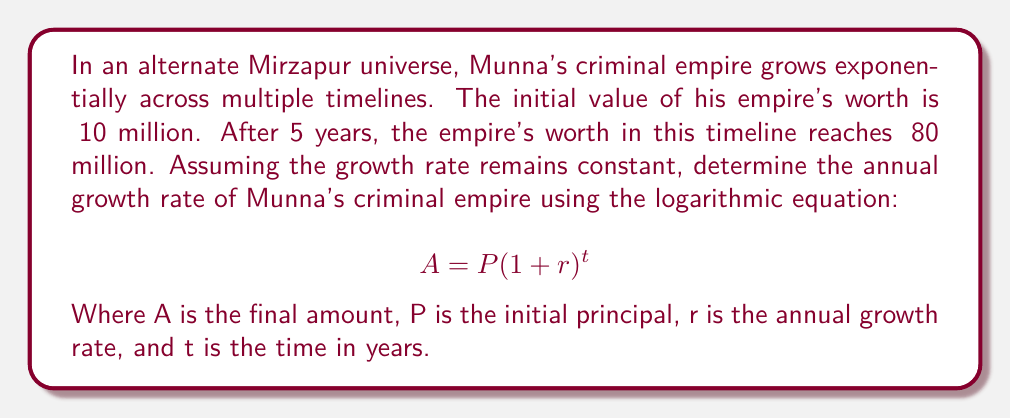Can you solve this math problem? Let's approach this step-by-step using the logarithmic properties:

1) We have the exponential growth formula: $A = P(1 + r)^t$

2) Given values:
   $P = 10$ million
   $A = 80$ million
   $t = 5$ years

3) Substituting these values into the equation:
   $80 = 10(1 + r)^5$

4) Divide both sides by 10:
   $8 = (1 + r)^5$

5) Take the natural logarithm of both sides:
   $\ln(8) = \ln((1 + r)^5)$

6) Use the logarithm property $\ln(x^n) = n\ln(x)$:
   $\ln(8) = 5\ln(1 + r)$

7) Divide both sides by 5:
   $\frac{\ln(8)}{5} = \ln(1 + r)$

8) Apply the exponential function to both sides:
   $e^{\frac{\ln(8)}{5}} = e^{\ln(1 + r)} = 1 + r$

9) Subtract 1 from both sides:
   $e^{\frac{\ln(8)}{5}} - 1 = r$

10) Calculate the value:
    $r = e^{\frac{\ln(8)}{5}} - 1 \approx 0.5189 - 1 = 0.5189$

11) Convert to percentage:
    $r \approx 0.5189 \times 100\% = 51.89\%$
Answer: The annual growth rate of Munna's criminal empire across multiple timelines is approximately 51.89%. 